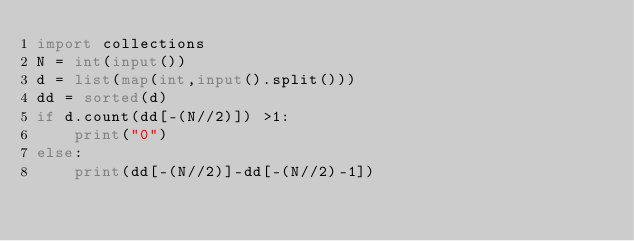Convert code to text. <code><loc_0><loc_0><loc_500><loc_500><_Python_>import collections
N = int(input())
d = list(map(int,input().split()))
dd = sorted(d)
if d.count(dd[-(N//2)]) >1:
    print("0")
else:
    print(dd[-(N//2)]-dd[-(N//2)-1])
    

    </code> 